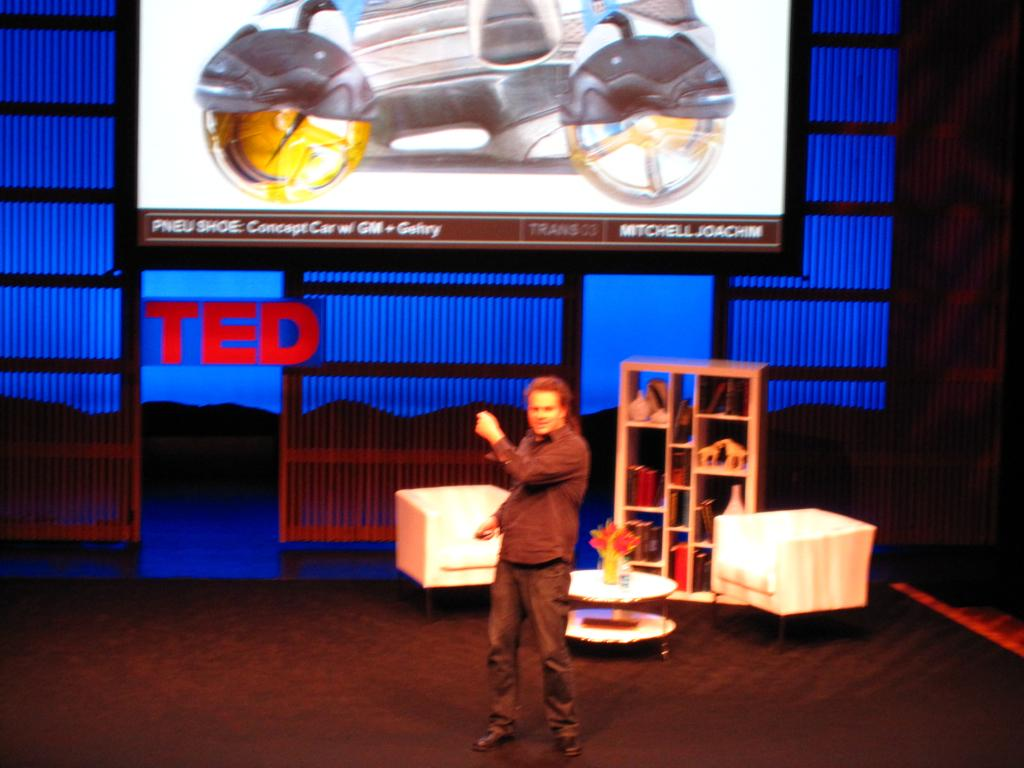What is the main subject of the image? There is a person standing on the stage. What can be seen in the background of the image? There are chairs, a rack, a table, a flower vase, and a screen in the background. Can you describe the objects on the stage? The image only shows a person standing on the stage, so there are no other objects on the stage. What type of lettuce is growing on the screen in the background? There is no lettuce present in the image, and the screen does not depict any plants or vegetation. 